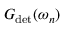Convert formula to latex. <formula><loc_0><loc_0><loc_500><loc_500>G _ { d e t } ( \omega _ { n } )</formula> 